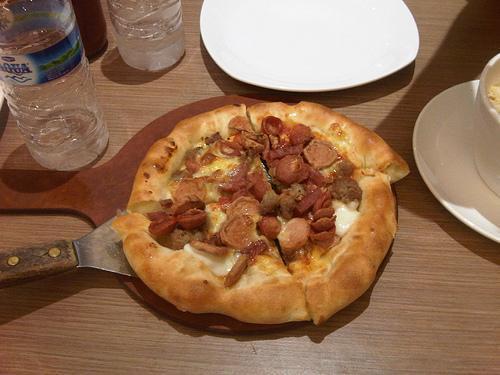How many bottles are there?
Give a very brief answer. 2. How many pizzas are in the picture?
Give a very brief answer. 1. How many people are carrying a bag?
Give a very brief answer. 0. 